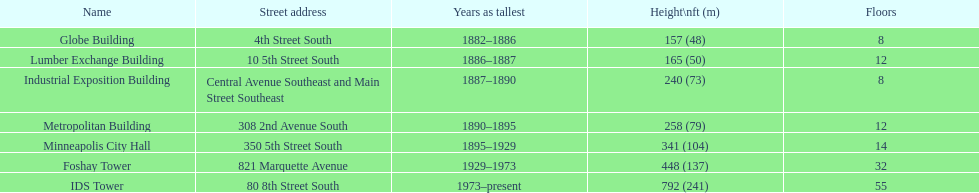How many buildings on the list are taller than 200 feet? 5. 